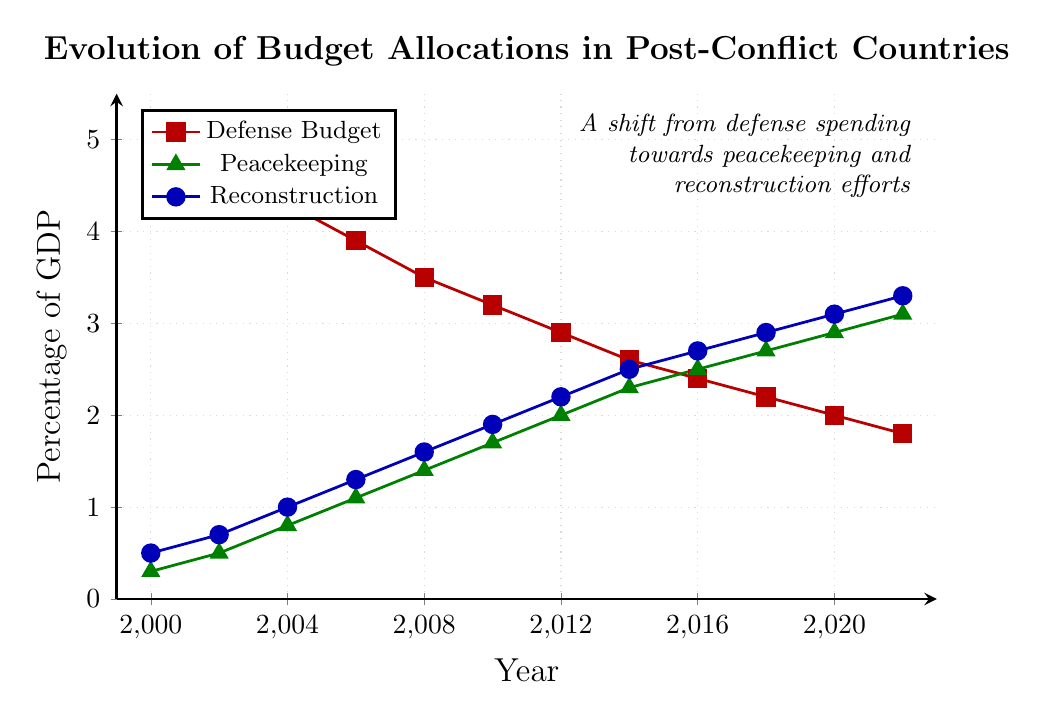Which category saw the largest increase from 2000 to 2022? To determine the largest increase, subtract the 2000 values from the 2022 values for each category. Defense: 1.8 - 5.2 = -3.4, Peacekeeping: 3.1 - 0.3 = 2.8, Reconstruction: 3.3 - 0.5 = 2.8. Both Peacekeeping and Reconstruction experienced the largest increases.
Answer: Peacekeeping and Reconstruction In what year did the defense budget fall below 3% of GDP? Observe the defense budget percentages over the years and identify when it first drops below 3%. In 2012, it is 2.9%.
Answer: 2012 What is the combined allocation for peacekeeping and reconstruction in 2018? Add the peacekeeping percentage and reconstruction percentage for 2018. 2.7 (Peacekeeping) + 2.9 (Reconstruction) = 5.6
Answer: 5.6 How does the trend in defense budget allocation compare to that of peacekeeping allocation? Examine the slopes of the defense and peacekeeping lines. The defense line shows a steady decline, whereas the peacekeeping line shows a steady increase across the same period.
Answer: Defense is decreasing, Peacekeeping is increasing Which category had the smallest allocation in 2006? Compare the allocations for all three categories in 2006. Defense: 3.9, Peacekeeping: 1.1, Reconstruction: 1.3. Peacekeeping has the smallest allocation.
Answer: Peacekeeping By how much did the reconstruction budget increase from 2000 to 2012? Calculate the difference between the reconstruction budget values for 2000 and 2012. 2.2 (2012) - 0.5 (2000) = 1.7
Answer: 1.7 What is the average defense budget allocation for the first four data points? Calculate the mean of the defense budget percentages for 2000, 2002, 2004, and 2006: (5.2 + 4.8 + 4.3 + 3.9) / 4 = 18.2 / 4 = 4.55
Answer: 4.55 Which year shows the highest percentage for peacekeeping? Look for the highest value in the peacekeeping data. The highest value is 3.1% in 2022.
Answer: 2022 What was the defense budget allocation difference between 2004 and 2014? Subtract the 2014 value from the 2004 value. 4.3 (2004) - 2.6 (2014) = 1.7
Answer: 1.7 Between 2008 and 2010, did the peacekeeping budget increase more or less than the reconstruction budget? Subtract the 2008 values from the 2010 values for both categories. Peacekeeping: 1.7 - 1.4 = 0.3, Reconstruction: 1.9 - 1.6 = 0.3. Both increased equally.
Answer: Equally 